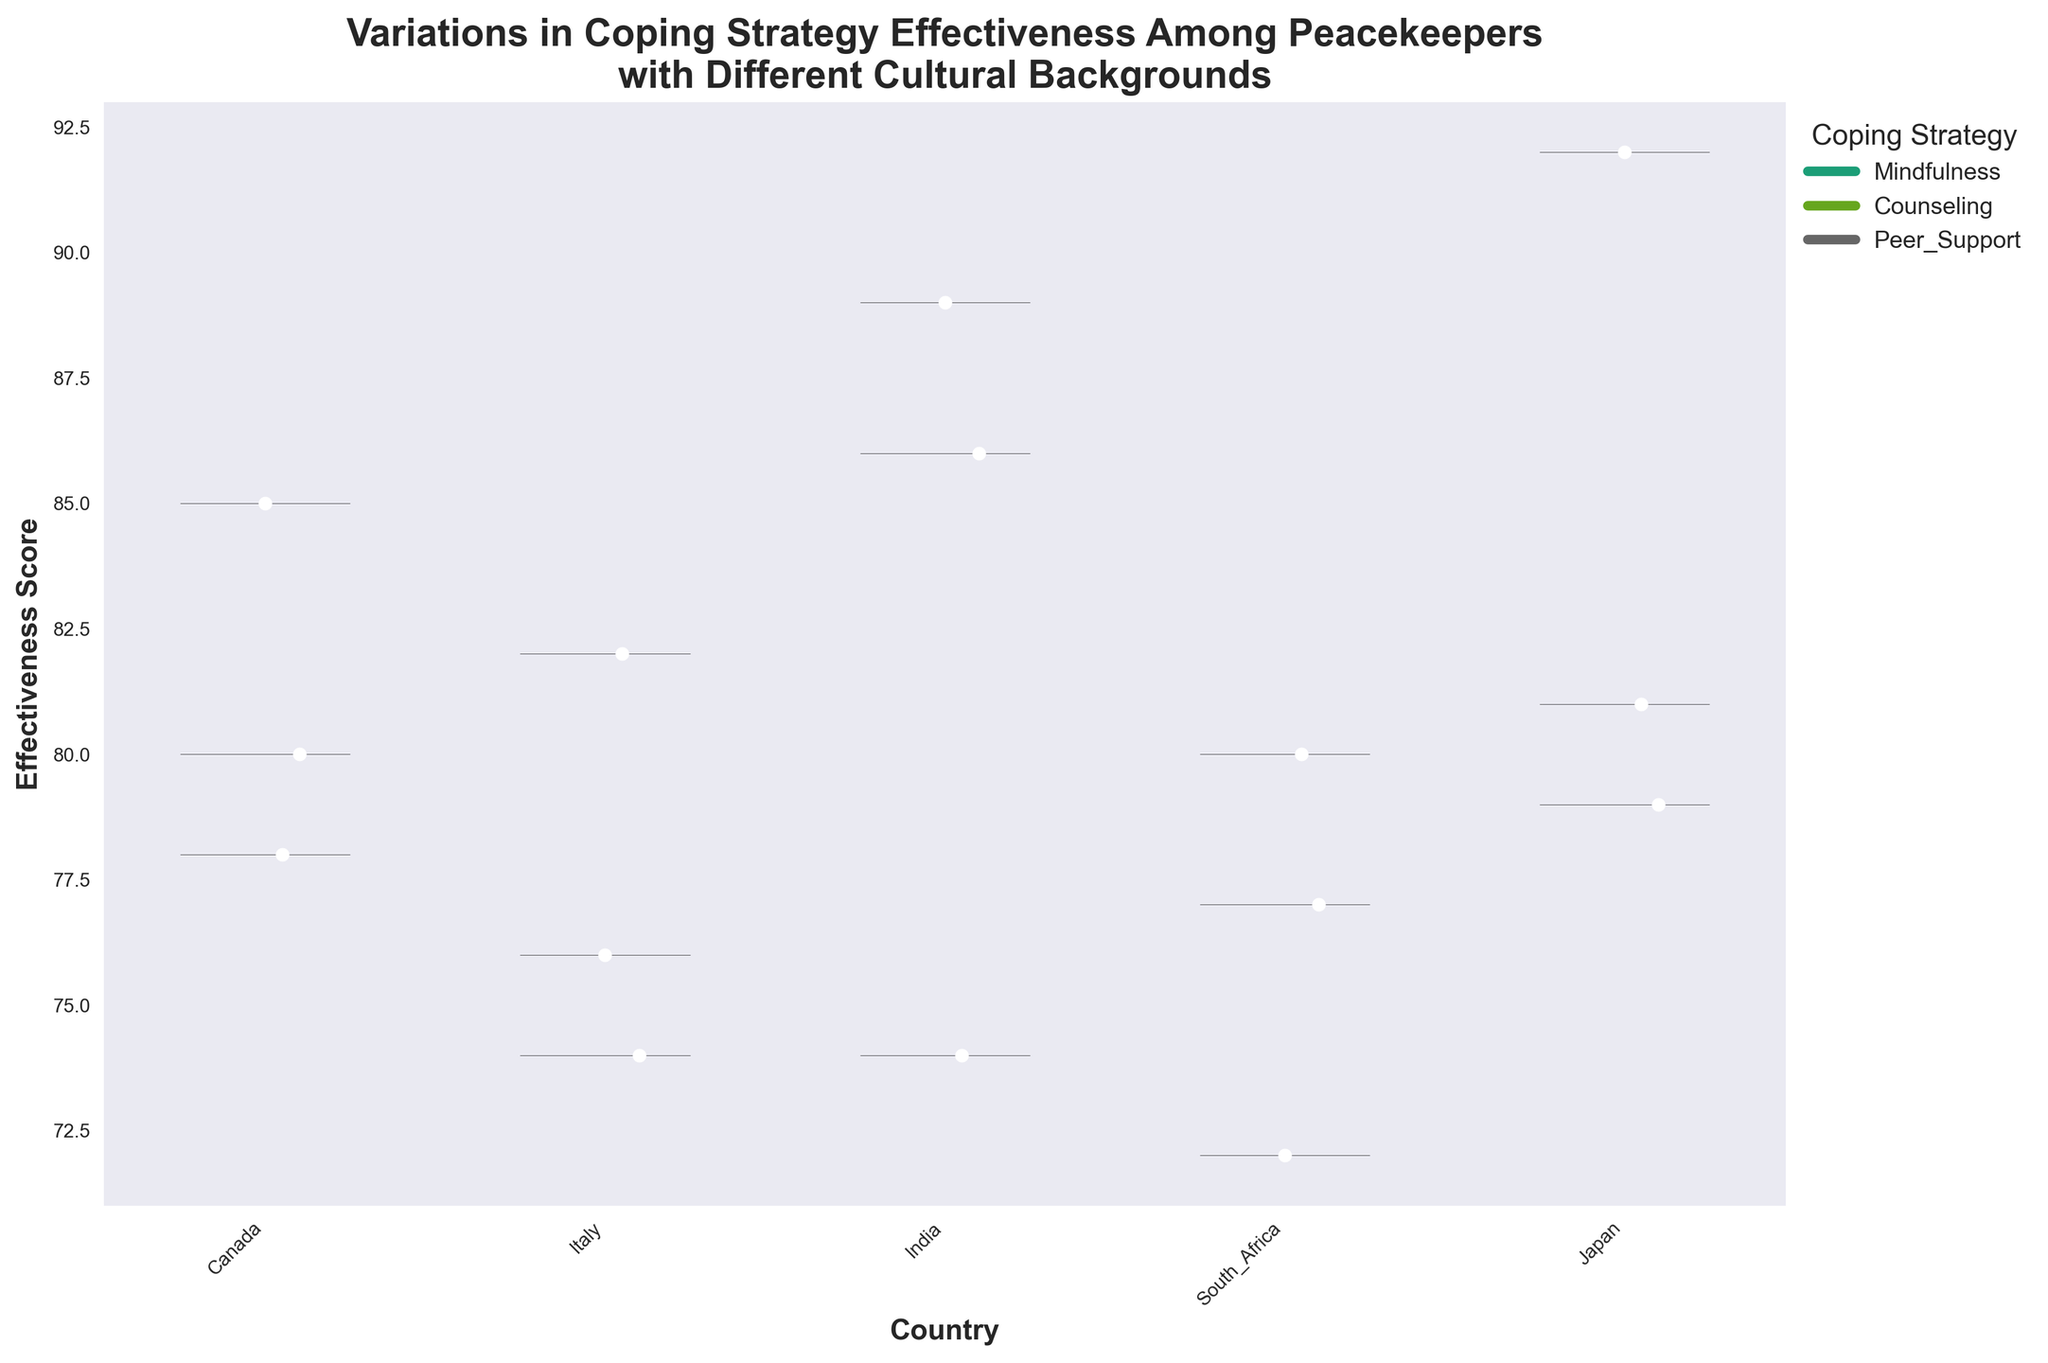What is the title of the chart? The title is usually displayed at the top of the chart and provides a brief description of the data being visualized. In this case, it summarizes the key theme.
Answer: "Variations in Coping Strategy Effectiveness Among Peacekeepers with Different Cultural Backgrounds" Which country shows the highest median effectiveness score for mindfulness? To determine this, first identify the median points for mindfulness from the chart for each country. Check which country's median point is the highest.
Answer: Japan What is the effectiveness score range for peer support in India? Locate the violins for peer support in India. Identify the extreme points (top and bottom) of the violin plot for peer support within India's section.
Answer: 86 to 86 Which coping strategy shows the largest variation in effectiveness scores across all countries? Observe the spread and width of the violin plots for each strategy. The one with the widest and most varied distribution indicates the largest variation.
Answer: Mindfulness How does the median effectiveness score of counseling in South Africa compare with that in Canada? Identify and compare the median points of counseling for South Africa and Canada from the chart.
Answer: South Africa: 80, Canada: 78 For which country is peer support the least effective? Check the lowest sections of the peer support violins across all countries. The country with the violin at the lowest position shows the least effective peer support.
Answer: Italy What is the relative position of the quartile ranges of mindfulness in Canada and Japan? Locate the quartile ranges (middle 50%) for mindfulness in both Canada and Japan. Compare their positions on the chart.
Answer: Japan's range is higher than Canada's Which coping strategy has the lowest overall effectiveness score in Italy? Consider the positions of the lowest points for each coping strategy in Italy. Select the one with the minimum value.
Answer: Peer Support Which country has the largest difference between the highest and lowest effectiveness scores for all coping strategies? Calculate the range (difference between the highest and lowest points) for each country's data across all strategies. The country with the widest range has the largest difference.
Answer: Canada What overall trend can be observed about the effectiveness of mindfulness across different countries? Analyze the positions and spreads of the mindfulness violins for all countries. Summarize the trend in terms of effectiveness scores.
Answer: Mindfulness shows high effectiveness in most countries, especially in Japan and Canada, with India also showing high scores but more variability 